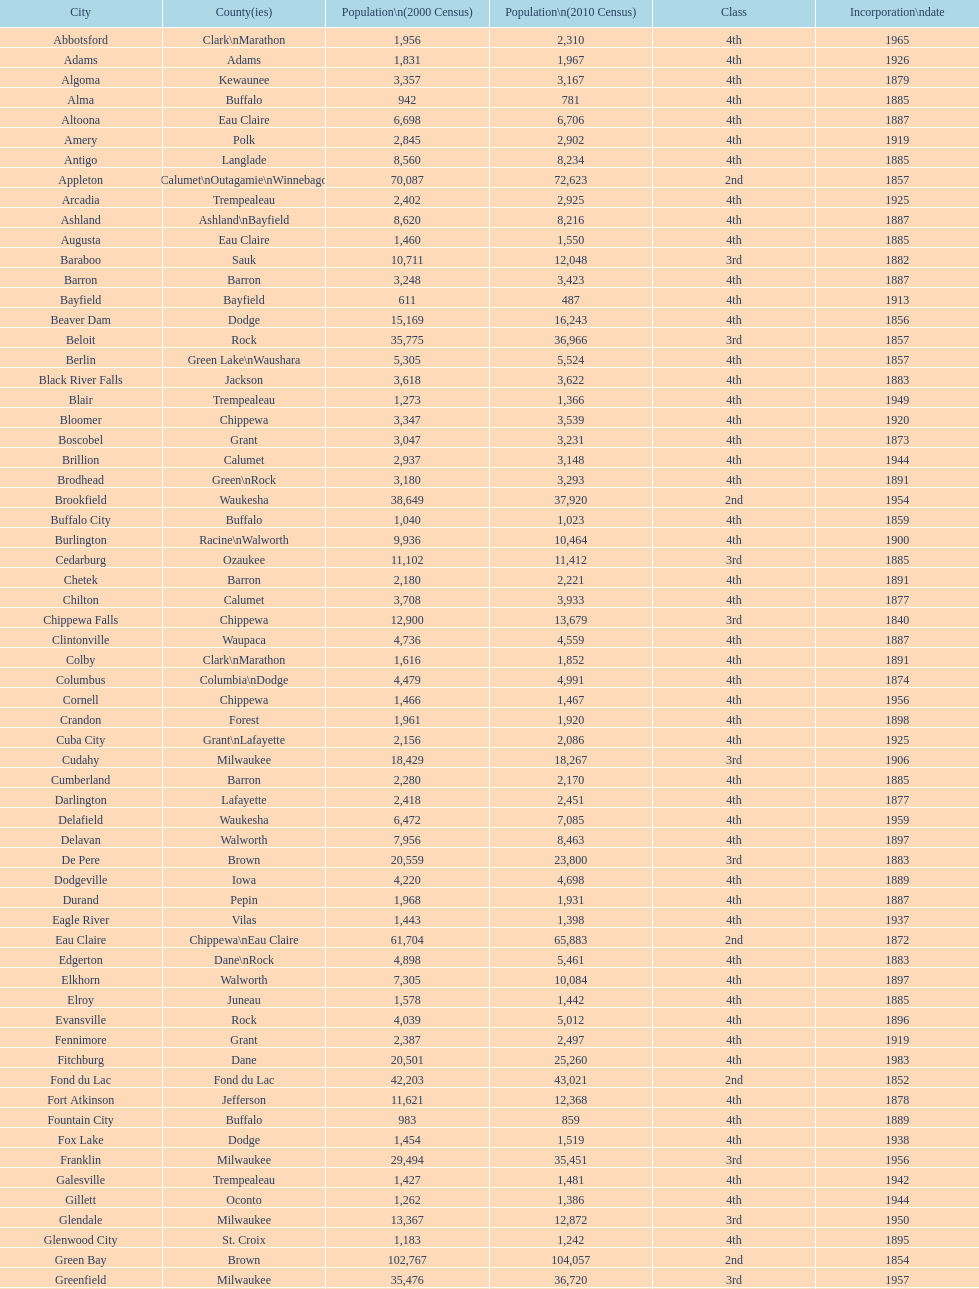Does the county contain altoona and augusta? Eau Claire. 